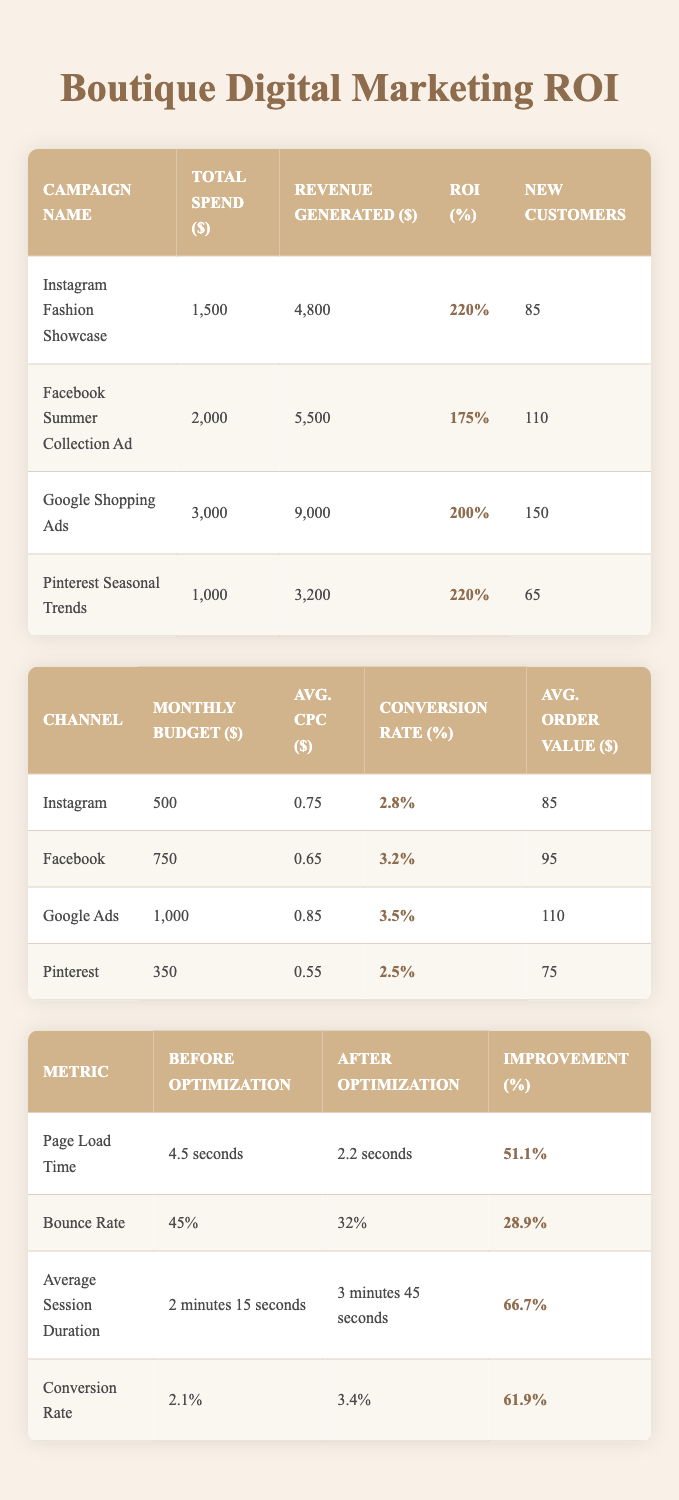What is the ROI percentage for the Instagram Fashion Showcase campaign? The table lists the ROI percentage for each campaign. For the Instagram Fashion Showcase campaign, it specifically states that the ROI percentage is 220%.
Answer: 220% Which campaign had the highest total spend? By comparing the total spend amounts across all campaigns, the Google Shopping Ads campaign has the highest total spend at $3,000.
Answer: Google Shopping Ads How many new customers were acquired from the Facebook Summer Collection Ad campaign? The table indicates that the Facebook Summer Collection Ad campaign acquired 110 new customers.
Answer: 110 What is the average ROI percentage of all the digital marketing campaigns listed? To find the average ROI percentage, we sum the ROI percentages of all campaigns: 220 + 175 + 200 + 220 = 815. Then, divide by the number of campaigns (4): 815 / 4 = 203.75.
Answer: 203.75 Does the Pinterest Seasonal Trends campaign have a higher ROI percentage than the Facebook Summer Collection Ad? The ROI percentage for the Pinterest Seasonal Trends campaign is 220%, while the Facebook Summer Collection Ad has 175%. Since 220% is greater than 175%, the statement is true.
Answer: Yes Which advertising channel has the lowest average cost per click (CPC)? Comparing the average CPC across all channels, Pinterest has the lowest average CPC at $0.55.
Answer: Pinterest What was the improvement percentage in average session duration before and after optimization? The table shows that the average session duration improved from 2 minutes 15 seconds to 3 minutes 45 seconds, resulting in an improvement percentage of 66.7%.
Answer: 66.7% If you add up the monthly budgets for all online advertising channels, what is the total? Summing the monthly budgets: 500 + 750 + 1000 + 350 = 2600.
Answer: 2600 Which digital marketing campaign had the least revenue generated? By comparing the revenue generated by each campaign, the Pinterest Seasonal Trends campaign generated the least revenue at $3,200.
Answer: Pinterest Seasonal Trends 